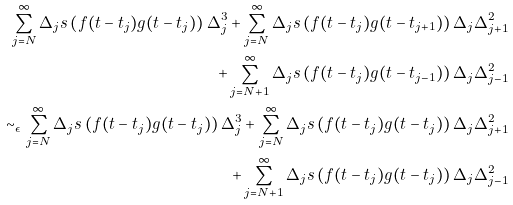Convert formula to latex. <formula><loc_0><loc_0><loc_500><loc_500>\sum _ { j = N } ^ { \infty } \Delta _ { j } s \left ( f ( t - t _ { j } ) g ( t - t _ { j } ) \right ) \Delta _ { j } ^ { 3 } + \sum _ { j = N } ^ { \infty } \Delta _ { j } s \left ( f ( t - t _ { j } ) g ( t - t _ { j + 1 } ) \right ) \Delta _ { j } \Delta _ { j + 1 } ^ { 2 } \\ + \sum _ { j = N + 1 } ^ { \infty } \Delta _ { j } s \left ( f ( t - t _ { j } ) g ( t - t _ { j - 1 } ) \right ) \Delta _ { j } \Delta _ { j - 1 } ^ { 2 } \\ \sim _ { \epsilon } \sum _ { j = N } ^ { \infty } \Delta _ { j } s \left ( f ( t - t _ { j } ) g ( t - t _ { j } ) \right ) \Delta _ { j } ^ { 3 } + \sum _ { j = N } ^ { \infty } \Delta _ { j } s \left ( f ( t - t _ { j } ) g ( t - t _ { j } ) \right ) \Delta _ { j } \Delta _ { j + 1 } ^ { 2 } \\ + \sum _ { j = N + 1 } ^ { \infty } \Delta _ { j } s \left ( f ( t - t _ { j } ) g ( t - t _ { j } ) \right ) \Delta _ { j } \Delta _ { j - 1 } ^ { 2 }</formula> 